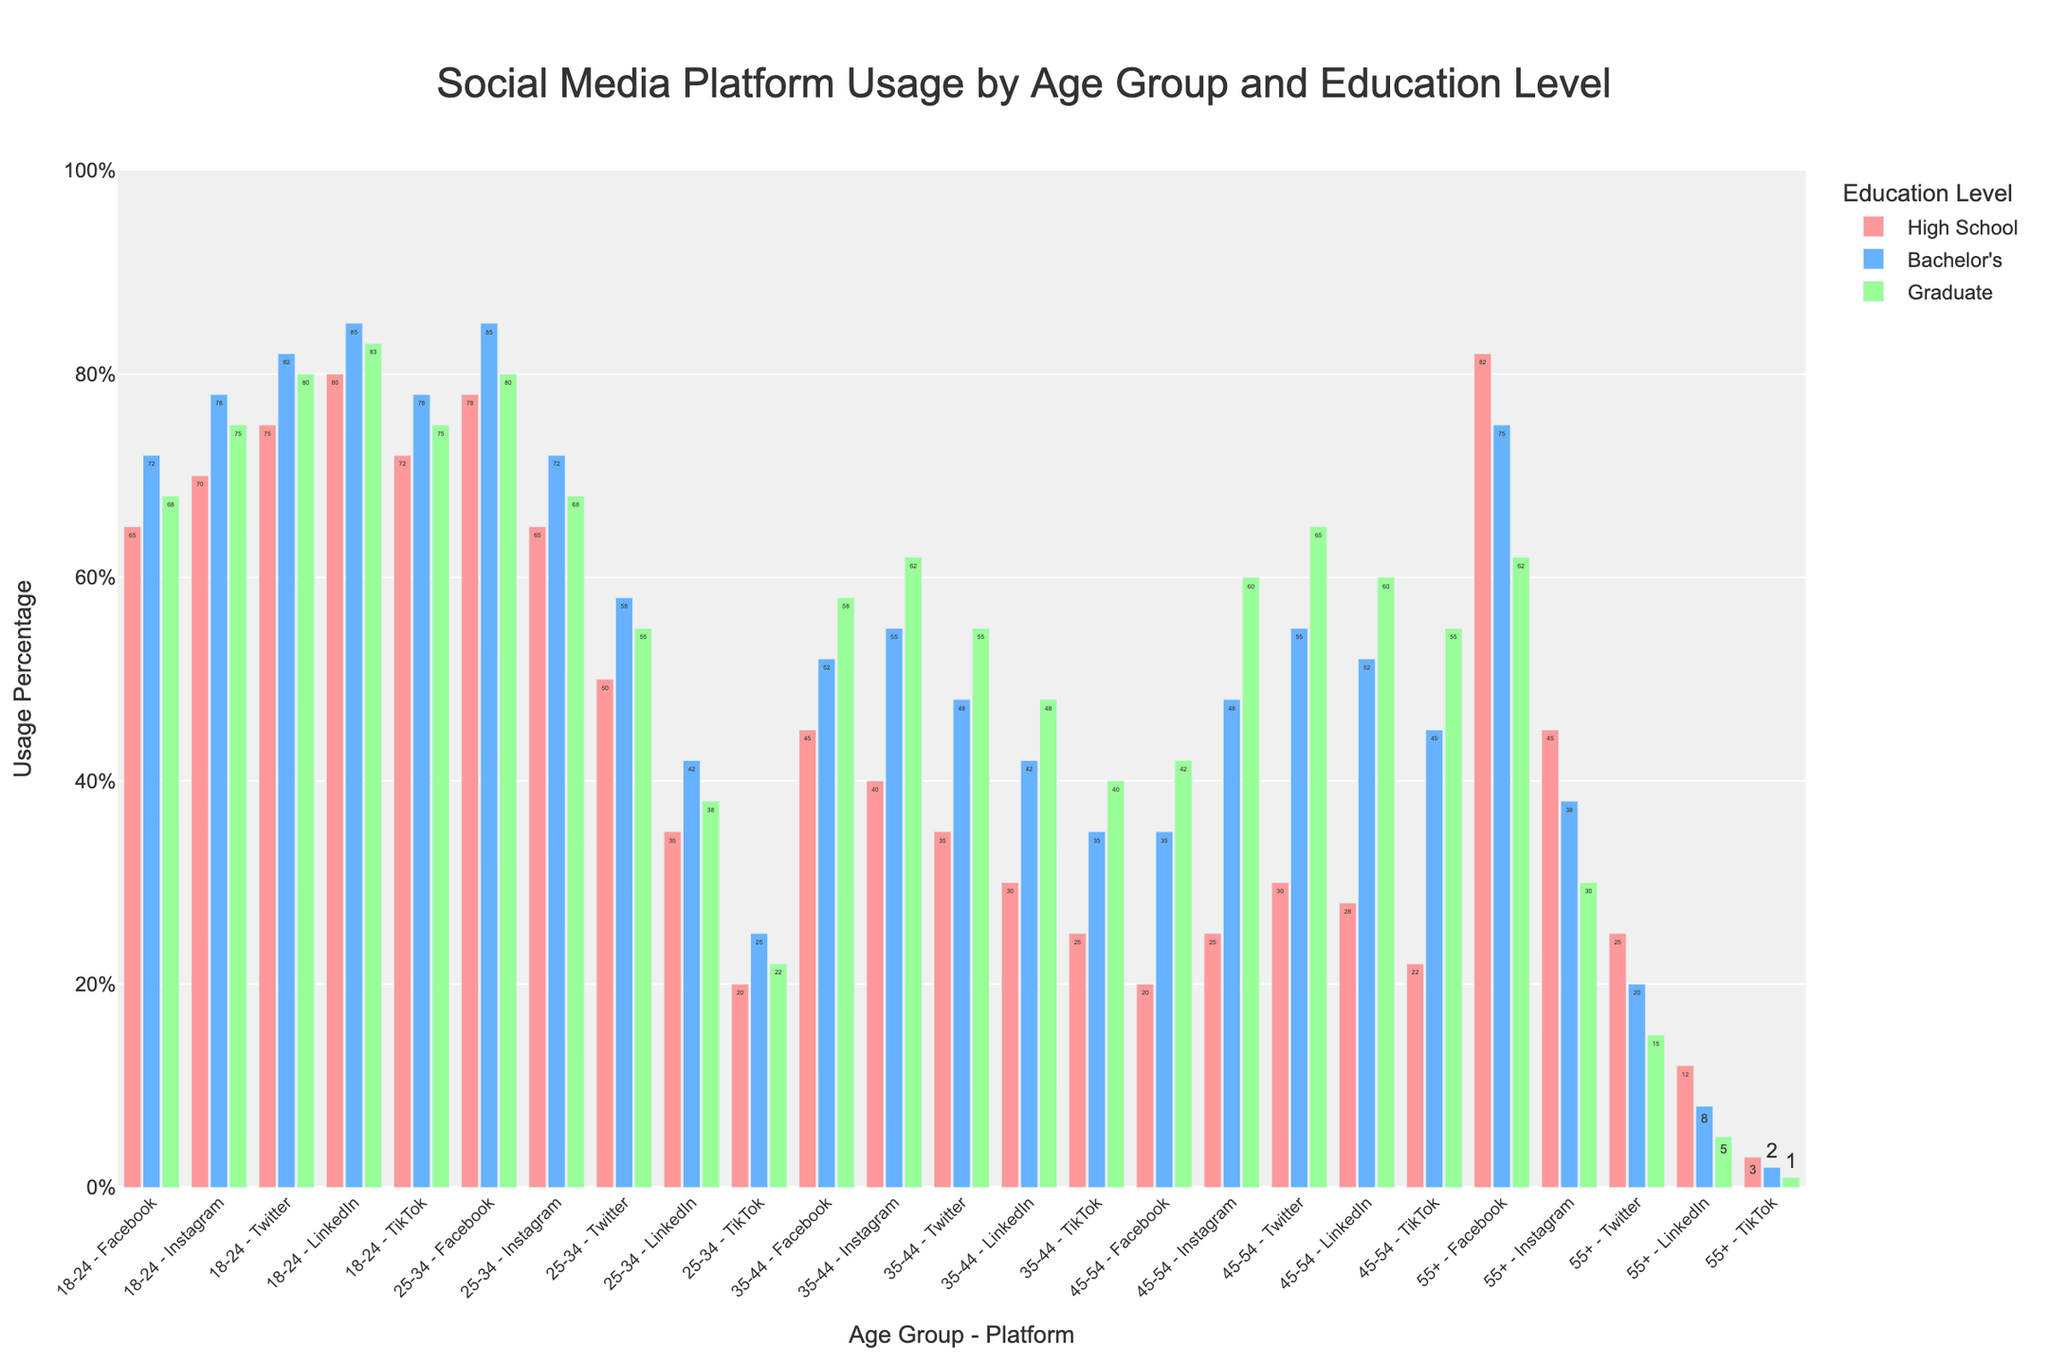Which age group has the highest Facebook usage among Bachelor's degree holders? Look for the bar with the highest value among Bachelor's degree holders in the Facebook category. The highest bar is within the 45-54 age group with 85% usage.
Answer: 45-54 What is the difference in Instagram usage between 18-24 year-olds with a high school diploma and those with a bachelor's degree? Find the Instagram usage values for 18-24 age group with high school diploma (78%) and bachelor's degree (85%). Subtract the former from the latter: 85% - 78% = 7%.
Answer: 7% Which social media platform has the lowest usage among all educational levels in the 55+ age group? Inspect all the platforms within the 55+ age group, noting their lowest usage across the educational levels. The platform with the lowest value is TikTok with 1% (Graduate level).
Answer: TikTok What is the average LinkedIn usage for 25-34 year-olds across all educational levels? Find the LinkedIn usage for 25-34 year-olds: High School (25%), Bachelor's (48%), Graduate (60%). Calculate the average: (25 + 48 + 60) / 3 = 44.33%.
Answer: 44.33% How does Twitter usage in the 35-44 age group with Bachelor's compare to those with Graduate degrees? Inspect Twitter usage for 35-44 age group with Bachelor's (48%) and Graduate degrees (55%). The Graduate level has a higher usage.
Answer: Higher for Graduate degrees Which color represents the bars for the usage data of High School education level? Observe the color attribute assigned to the High School education level group. It is represented by red-colored bars.
Answer: Red Among 25-34 year-olds, which social media platform shows the largest decrease in usage when moving from Bachelor's to Graduate degrees? Note the usage values for 25-34 year-olds with Bachelor's and Graduate degrees across all platforms. Find the largest decrease (difference): Facebook (78% to 75%), Instagram (72% to 68%), Twitter (55% to 62%), LinkedIn (48% to 60%), TikTok (38% to 30%). The largest decrease is TikTok, with a difference of 38% - 30% = 8%.
Answer: TikTok Is Instagram more popular among 18-24 year-olds with Graduate degrees or 25-34 year-olds with Bachelor's degrees? Compare Instagram usage: 18-24 (Graduate, 80%) and 25-34 (Bachelor’s, 72%). Instagram is more popular among 18-24 year-olds with Graduate degrees.
Answer: 18-24 (Graduate degrees) What is the total Facebook usage for 55+ age group across all educational levels? Add the Facebook usage values for the 55+ age group: 72% (High School) + 78% (Bachelor's) + 75% (Graduate) = 225%.
Answer: 225% What is the ratio of TikTok usage between 18-24 year-olds with a bachelor’s degree and 45-54 year-olds with a high school diploma? Note the TikTok usage for 18-24 (Bachelor's, 75%) and 45-54 (High School, 12%). Calculate the ratio: 75 / 12 = 6.25.
Answer: 6.25 